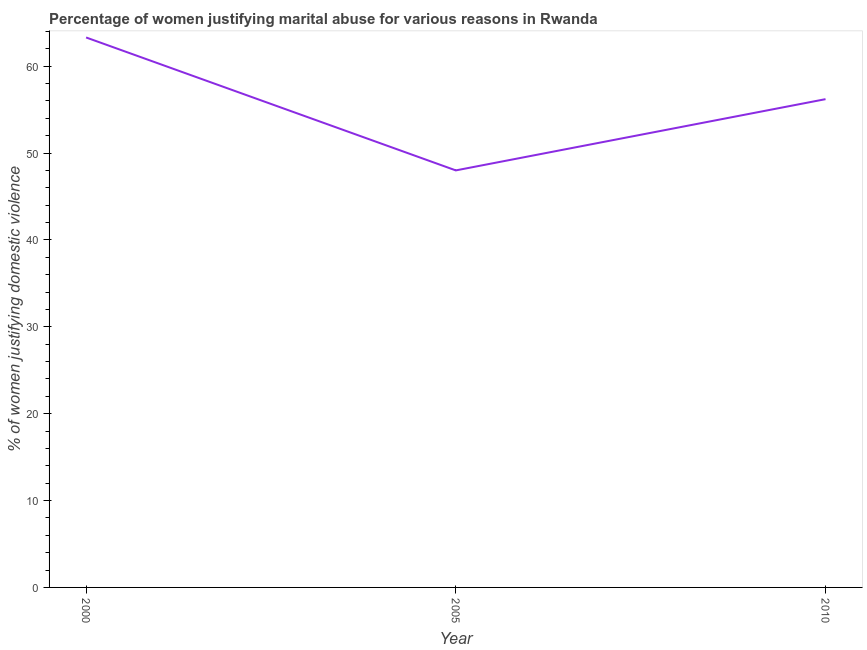What is the percentage of women justifying marital abuse in 2000?
Your response must be concise. 63.3. Across all years, what is the maximum percentage of women justifying marital abuse?
Give a very brief answer. 63.3. In which year was the percentage of women justifying marital abuse maximum?
Provide a succinct answer. 2000. What is the sum of the percentage of women justifying marital abuse?
Provide a succinct answer. 167.5. What is the difference between the percentage of women justifying marital abuse in 2000 and 2005?
Keep it short and to the point. 15.3. What is the average percentage of women justifying marital abuse per year?
Your answer should be very brief. 55.83. What is the median percentage of women justifying marital abuse?
Make the answer very short. 56.2. Do a majority of the years between 2010 and 2005 (inclusive) have percentage of women justifying marital abuse greater than 20 %?
Ensure brevity in your answer.  No. What is the ratio of the percentage of women justifying marital abuse in 2000 to that in 2010?
Your answer should be compact. 1.13. Is the difference between the percentage of women justifying marital abuse in 2000 and 2005 greater than the difference between any two years?
Give a very brief answer. Yes. What is the difference between the highest and the second highest percentage of women justifying marital abuse?
Keep it short and to the point. 7.1. What is the difference between the highest and the lowest percentage of women justifying marital abuse?
Ensure brevity in your answer.  15.3. How many lines are there?
Offer a terse response. 1. Are the values on the major ticks of Y-axis written in scientific E-notation?
Your answer should be very brief. No. What is the title of the graph?
Ensure brevity in your answer.  Percentage of women justifying marital abuse for various reasons in Rwanda. What is the label or title of the X-axis?
Keep it short and to the point. Year. What is the label or title of the Y-axis?
Provide a short and direct response. % of women justifying domestic violence. What is the % of women justifying domestic violence of 2000?
Provide a short and direct response. 63.3. What is the % of women justifying domestic violence in 2010?
Offer a very short reply. 56.2. What is the difference between the % of women justifying domestic violence in 2000 and 2005?
Ensure brevity in your answer.  15.3. What is the difference between the % of women justifying domestic violence in 2005 and 2010?
Ensure brevity in your answer.  -8.2. What is the ratio of the % of women justifying domestic violence in 2000 to that in 2005?
Offer a very short reply. 1.32. What is the ratio of the % of women justifying domestic violence in 2000 to that in 2010?
Make the answer very short. 1.13. What is the ratio of the % of women justifying domestic violence in 2005 to that in 2010?
Give a very brief answer. 0.85. 